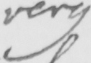What does this handwritten line say? very 